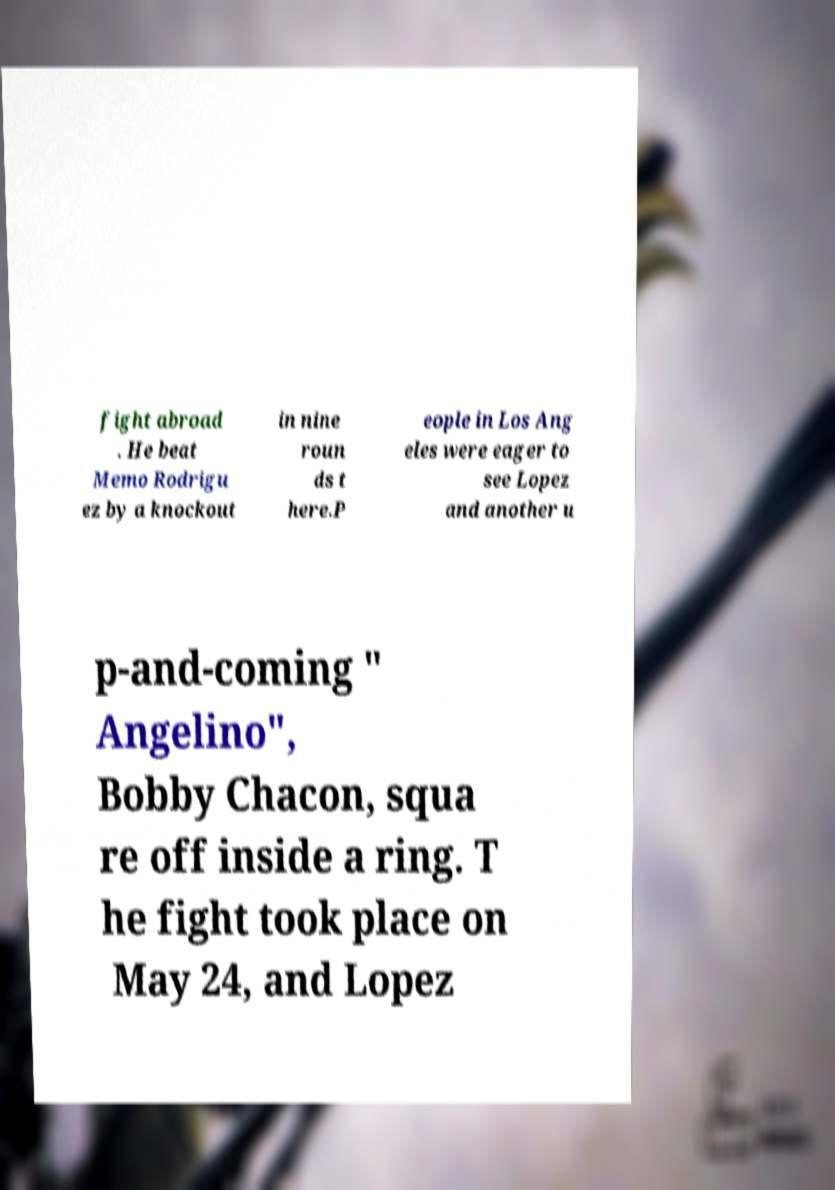I need the written content from this picture converted into text. Can you do that? fight abroad . He beat Memo Rodrigu ez by a knockout in nine roun ds t here.P eople in Los Ang eles were eager to see Lopez and another u p-and-coming " Angelino", Bobby Chacon, squa re off inside a ring. T he fight took place on May 24, and Lopez 